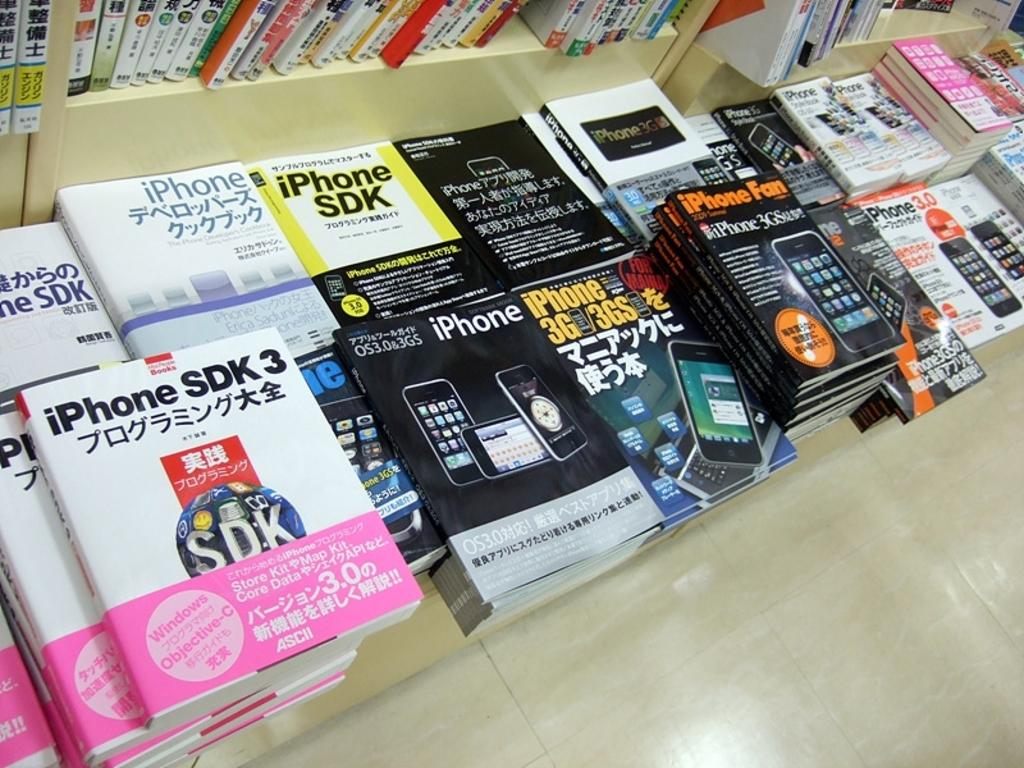<image>
Relay a brief, clear account of the picture shown. On the left side of a stack of books is a book named iPhone SDK 3. 